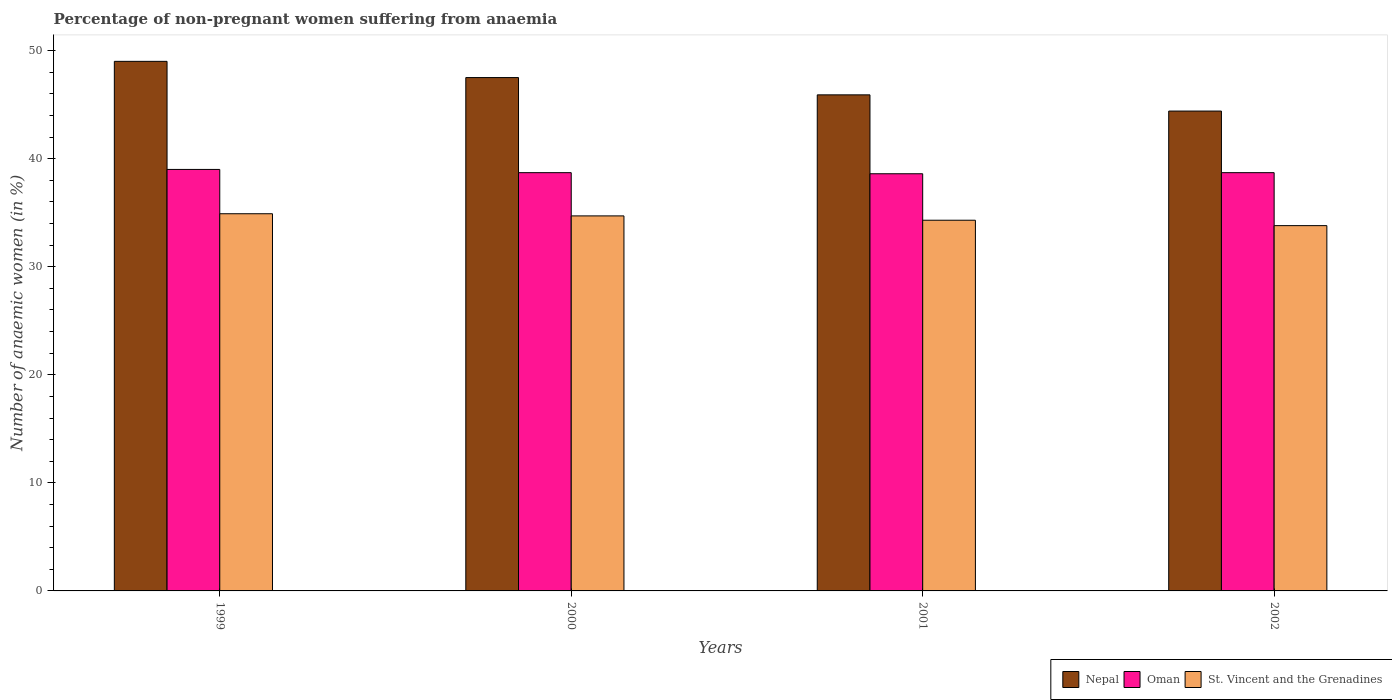How many different coloured bars are there?
Your response must be concise. 3. How many groups of bars are there?
Your answer should be very brief. 4. Are the number of bars per tick equal to the number of legend labels?
Provide a short and direct response. Yes. Are the number of bars on each tick of the X-axis equal?
Provide a succinct answer. Yes. How many bars are there on the 3rd tick from the left?
Ensure brevity in your answer.  3. What is the percentage of non-pregnant women suffering from anaemia in St. Vincent and the Grenadines in 2000?
Keep it short and to the point. 34.7. Across all years, what is the maximum percentage of non-pregnant women suffering from anaemia in St. Vincent and the Grenadines?
Ensure brevity in your answer.  34.9. Across all years, what is the minimum percentage of non-pregnant women suffering from anaemia in St. Vincent and the Grenadines?
Offer a terse response. 33.8. In which year was the percentage of non-pregnant women suffering from anaemia in Nepal maximum?
Offer a terse response. 1999. In which year was the percentage of non-pregnant women suffering from anaemia in Nepal minimum?
Offer a terse response. 2002. What is the total percentage of non-pregnant women suffering from anaemia in St. Vincent and the Grenadines in the graph?
Your response must be concise. 137.7. What is the difference between the percentage of non-pregnant women suffering from anaemia in St. Vincent and the Grenadines in 1999 and that in 2000?
Your response must be concise. 0.2. What is the difference between the percentage of non-pregnant women suffering from anaemia in St. Vincent and the Grenadines in 2002 and the percentage of non-pregnant women suffering from anaemia in Nepal in 1999?
Make the answer very short. -15.2. What is the average percentage of non-pregnant women suffering from anaemia in Nepal per year?
Your answer should be very brief. 46.7. In the year 2000, what is the difference between the percentage of non-pregnant women suffering from anaemia in St. Vincent and the Grenadines and percentage of non-pregnant women suffering from anaemia in Oman?
Keep it short and to the point. -4. What is the ratio of the percentage of non-pregnant women suffering from anaemia in St. Vincent and the Grenadines in 1999 to that in 2000?
Give a very brief answer. 1.01. Is the difference between the percentage of non-pregnant women suffering from anaemia in St. Vincent and the Grenadines in 2000 and 2001 greater than the difference between the percentage of non-pregnant women suffering from anaemia in Oman in 2000 and 2001?
Your answer should be very brief. Yes. What is the difference between the highest and the lowest percentage of non-pregnant women suffering from anaemia in Nepal?
Ensure brevity in your answer.  4.6. Is the sum of the percentage of non-pregnant women suffering from anaemia in Oman in 2000 and 2002 greater than the maximum percentage of non-pregnant women suffering from anaemia in Nepal across all years?
Give a very brief answer. Yes. What does the 2nd bar from the left in 2002 represents?
Provide a short and direct response. Oman. What does the 3rd bar from the right in 1999 represents?
Give a very brief answer. Nepal. Is it the case that in every year, the sum of the percentage of non-pregnant women suffering from anaemia in Nepal and percentage of non-pregnant women suffering from anaemia in Oman is greater than the percentage of non-pregnant women suffering from anaemia in St. Vincent and the Grenadines?
Offer a very short reply. Yes. How many bars are there?
Offer a terse response. 12. Are all the bars in the graph horizontal?
Make the answer very short. No. How many years are there in the graph?
Provide a short and direct response. 4. How many legend labels are there?
Offer a very short reply. 3. What is the title of the graph?
Give a very brief answer. Percentage of non-pregnant women suffering from anaemia. What is the label or title of the X-axis?
Keep it short and to the point. Years. What is the label or title of the Y-axis?
Provide a succinct answer. Number of anaemic women (in %). What is the Number of anaemic women (in %) in Oman in 1999?
Give a very brief answer. 39. What is the Number of anaemic women (in %) in St. Vincent and the Grenadines in 1999?
Ensure brevity in your answer.  34.9. What is the Number of anaemic women (in %) in Nepal in 2000?
Your answer should be compact. 47.5. What is the Number of anaemic women (in %) of Oman in 2000?
Offer a very short reply. 38.7. What is the Number of anaemic women (in %) in St. Vincent and the Grenadines in 2000?
Your response must be concise. 34.7. What is the Number of anaemic women (in %) of Nepal in 2001?
Keep it short and to the point. 45.9. What is the Number of anaemic women (in %) of Oman in 2001?
Your answer should be very brief. 38.6. What is the Number of anaemic women (in %) in St. Vincent and the Grenadines in 2001?
Offer a very short reply. 34.3. What is the Number of anaemic women (in %) in Nepal in 2002?
Ensure brevity in your answer.  44.4. What is the Number of anaemic women (in %) in Oman in 2002?
Provide a succinct answer. 38.7. What is the Number of anaemic women (in %) in St. Vincent and the Grenadines in 2002?
Give a very brief answer. 33.8. Across all years, what is the maximum Number of anaemic women (in %) of Oman?
Give a very brief answer. 39. Across all years, what is the maximum Number of anaemic women (in %) of St. Vincent and the Grenadines?
Your response must be concise. 34.9. Across all years, what is the minimum Number of anaemic women (in %) in Nepal?
Offer a terse response. 44.4. Across all years, what is the minimum Number of anaemic women (in %) in Oman?
Ensure brevity in your answer.  38.6. Across all years, what is the minimum Number of anaemic women (in %) of St. Vincent and the Grenadines?
Give a very brief answer. 33.8. What is the total Number of anaemic women (in %) in Nepal in the graph?
Offer a very short reply. 186.8. What is the total Number of anaemic women (in %) of Oman in the graph?
Make the answer very short. 155. What is the total Number of anaemic women (in %) of St. Vincent and the Grenadines in the graph?
Give a very brief answer. 137.7. What is the difference between the Number of anaemic women (in %) of Nepal in 1999 and that in 2000?
Your answer should be compact. 1.5. What is the difference between the Number of anaemic women (in %) in Oman in 1999 and that in 2000?
Offer a very short reply. 0.3. What is the difference between the Number of anaemic women (in %) of St. Vincent and the Grenadines in 1999 and that in 2001?
Give a very brief answer. 0.6. What is the difference between the Number of anaemic women (in %) of Nepal in 1999 and that in 2002?
Give a very brief answer. 4.6. What is the difference between the Number of anaemic women (in %) in Oman in 1999 and that in 2002?
Offer a terse response. 0.3. What is the difference between the Number of anaemic women (in %) of Nepal in 2000 and that in 2001?
Ensure brevity in your answer.  1.6. What is the difference between the Number of anaemic women (in %) in St. Vincent and the Grenadines in 2000 and that in 2001?
Provide a short and direct response. 0.4. What is the difference between the Number of anaemic women (in %) in Nepal in 2000 and that in 2002?
Keep it short and to the point. 3.1. What is the difference between the Number of anaemic women (in %) in Oman in 2000 and that in 2002?
Provide a succinct answer. 0. What is the difference between the Number of anaemic women (in %) of Nepal in 2001 and that in 2002?
Keep it short and to the point. 1.5. What is the difference between the Number of anaemic women (in %) of St. Vincent and the Grenadines in 2001 and that in 2002?
Your answer should be compact. 0.5. What is the difference between the Number of anaemic women (in %) in Nepal in 1999 and the Number of anaemic women (in %) in Oman in 2001?
Provide a short and direct response. 10.4. What is the difference between the Number of anaemic women (in %) of Oman in 1999 and the Number of anaemic women (in %) of St. Vincent and the Grenadines in 2001?
Your answer should be very brief. 4.7. What is the difference between the Number of anaemic women (in %) of Nepal in 1999 and the Number of anaemic women (in %) of Oman in 2002?
Keep it short and to the point. 10.3. What is the difference between the Number of anaemic women (in %) in Nepal in 1999 and the Number of anaemic women (in %) in St. Vincent and the Grenadines in 2002?
Give a very brief answer. 15.2. What is the difference between the Number of anaemic women (in %) in Nepal in 2000 and the Number of anaemic women (in %) in Oman in 2001?
Your response must be concise. 8.9. What is the difference between the Number of anaemic women (in %) in Nepal in 2000 and the Number of anaemic women (in %) in St. Vincent and the Grenadines in 2001?
Your answer should be very brief. 13.2. What is the difference between the Number of anaemic women (in %) of Nepal in 2000 and the Number of anaemic women (in %) of St. Vincent and the Grenadines in 2002?
Give a very brief answer. 13.7. What is the difference between the Number of anaemic women (in %) of Oman in 2001 and the Number of anaemic women (in %) of St. Vincent and the Grenadines in 2002?
Your answer should be very brief. 4.8. What is the average Number of anaemic women (in %) in Nepal per year?
Provide a short and direct response. 46.7. What is the average Number of anaemic women (in %) in Oman per year?
Your answer should be compact. 38.75. What is the average Number of anaemic women (in %) in St. Vincent and the Grenadines per year?
Ensure brevity in your answer.  34.42. In the year 2000, what is the difference between the Number of anaemic women (in %) of Nepal and Number of anaemic women (in %) of St. Vincent and the Grenadines?
Keep it short and to the point. 12.8. In the year 2001, what is the difference between the Number of anaemic women (in %) in Nepal and Number of anaemic women (in %) in St. Vincent and the Grenadines?
Keep it short and to the point. 11.6. In the year 2002, what is the difference between the Number of anaemic women (in %) in Oman and Number of anaemic women (in %) in St. Vincent and the Grenadines?
Provide a short and direct response. 4.9. What is the ratio of the Number of anaemic women (in %) of Nepal in 1999 to that in 2000?
Provide a short and direct response. 1.03. What is the ratio of the Number of anaemic women (in %) of Nepal in 1999 to that in 2001?
Provide a short and direct response. 1.07. What is the ratio of the Number of anaemic women (in %) in Oman in 1999 to that in 2001?
Offer a very short reply. 1.01. What is the ratio of the Number of anaemic women (in %) in St. Vincent and the Grenadines in 1999 to that in 2001?
Ensure brevity in your answer.  1.02. What is the ratio of the Number of anaemic women (in %) of Nepal in 1999 to that in 2002?
Give a very brief answer. 1.1. What is the ratio of the Number of anaemic women (in %) of St. Vincent and the Grenadines in 1999 to that in 2002?
Provide a short and direct response. 1.03. What is the ratio of the Number of anaemic women (in %) of Nepal in 2000 to that in 2001?
Your response must be concise. 1.03. What is the ratio of the Number of anaemic women (in %) of Oman in 2000 to that in 2001?
Keep it short and to the point. 1. What is the ratio of the Number of anaemic women (in %) of St. Vincent and the Grenadines in 2000 to that in 2001?
Keep it short and to the point. 1.01. What is the ratio of the Number of anaemic women (in %) of Nepal in 2000 to that in 2002?
Offer a terse response. 1.07. What is the ratio of the Number of anaemic women (in %) of Oman in 2000 to that in 2002?
Keep it short and to the point. 1. What is the ratio of the Number of anaemic women (in %) in St. Vincent and the Grenadines in 2000 to that in 2002?
Your answer should be very brief. 1.03. What is the ratio of the Number of anaemic women (in %) of Nepal in 2001 to that in 2002?
Offer a very short reply. 1.03. What is the ratio of the Number of anaemic women (in %) in Oman in 2001 to that in 2002?
Make the answer very short. 1. What is the ratio of the Number of anaemic women (in %) of St. Vincent and the Grenadines in 2001 to that in 2002?
Provide a short and direct response. 1.01. What is the difference between the highest and the second highest Number of anaemic women (in %) of Oman?
Provide a succinct answer. 0.3. What is the difference between the highest and the second highest Number of anaemic women (in %) in St. Vincent and the Grenadines?
Give a very brief answer. 0.2. What is the difference between the highest and the lowest Number of anaemic women (in %) in Nepal?
Make the answer very short. 4.6. 